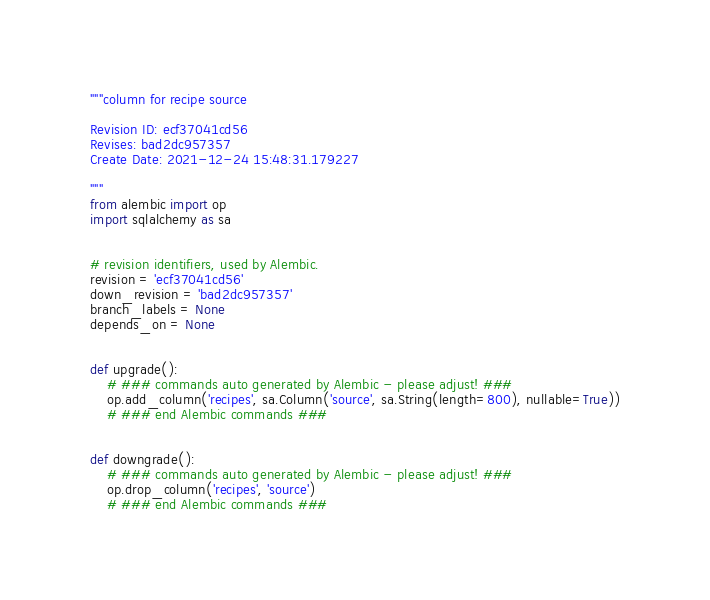Convert code to text. <code><loc_0><loc_0><loc_500><loc_500><_Python_>"""column for recipe source

Revision ID: ecf37041cd56
Revises: bad2dc957357
Create Date: 2021-12-24 15:48:31.179227

"""
from alembic import op
import sqlalchemy as sa


# revision identifiers, used by Alembic.
revision = 'ecf37041cd56'
down_revision = 'bad2dc957357'
branch_labels = None
depends_on = None


def upgrade():
    # ### commands auto generated by Alembic - please adjust! ###
    op.add_column('recipes', sa.Column('source', sa.String(length=800), nullable=True))
    # ### end Alembic commands ###


def downgrade():
    # ### commands auto generated by Alembic - please adjust! ###
    op.drop_column('recipes', 'source')
    # ### end Alembic commands ###
</code> 